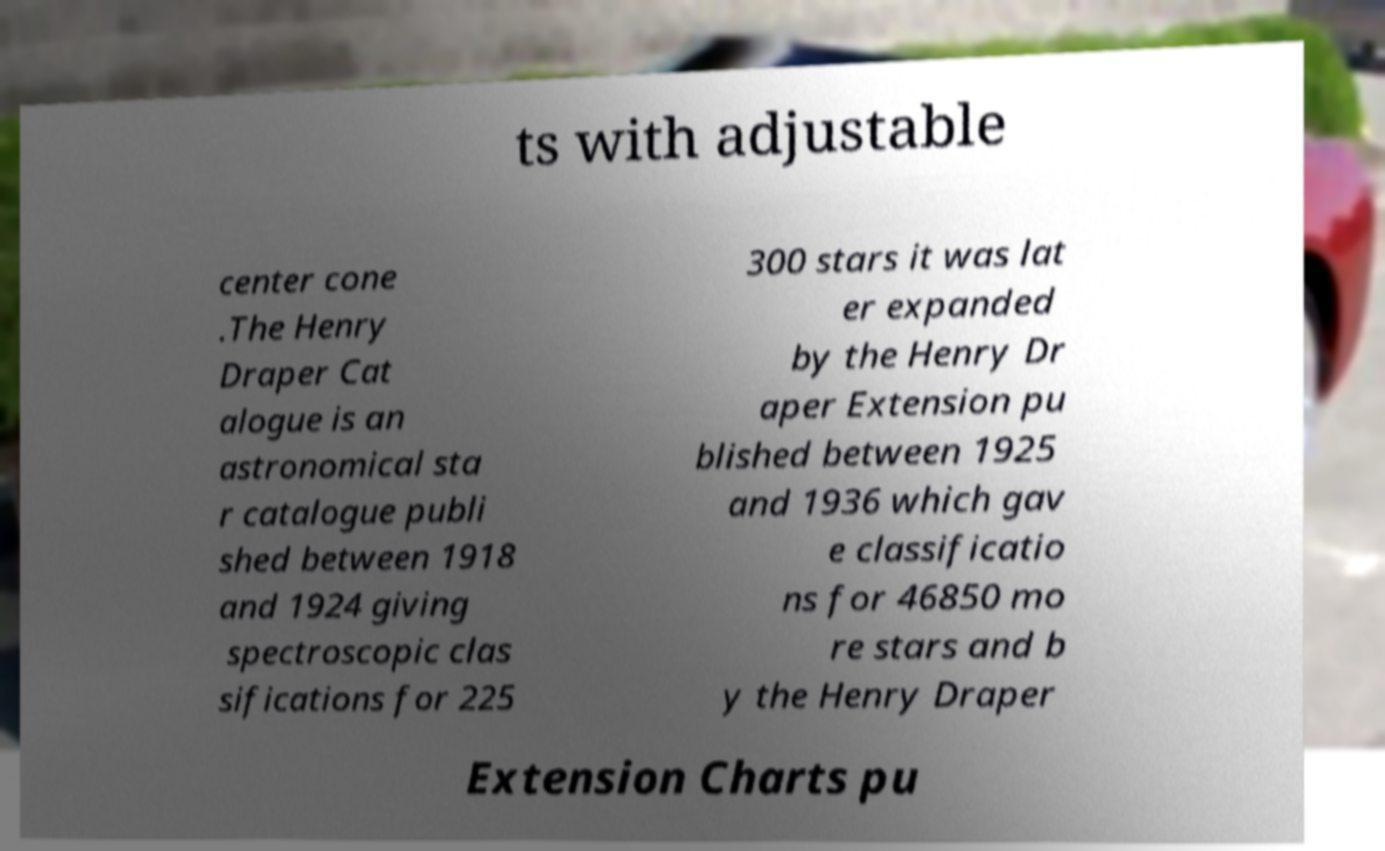Could you extract and type out the text from this image? ts with adjustable center cone .The Henry Draper Cat alogue is an astronomical sta r catalogue publi shed between 1918 and 1924 giving spectroscopic clas sifications for 225 300 stars it was lat er expanded by the Henry Dr aper Extension pu blished between 1925 and 1936 which gav e classificatio ns for 46850 mo re stars and b y the Henry Draper Extension Charts pu 